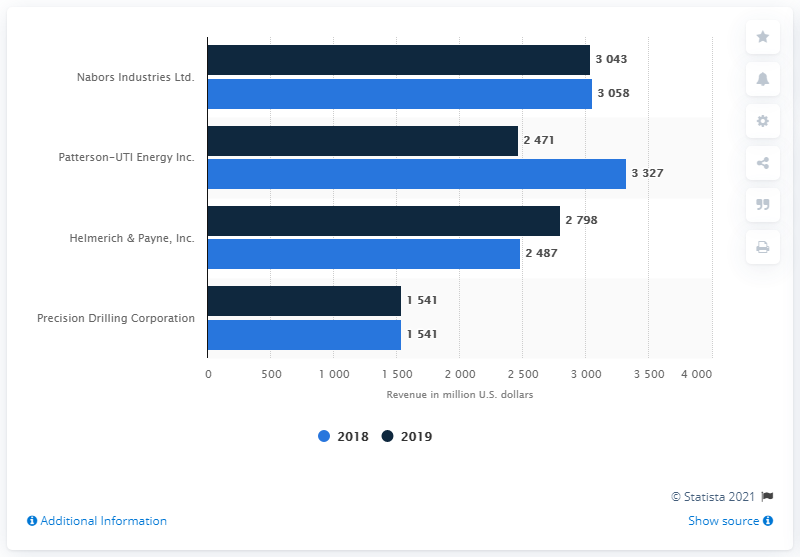Point out several critical features in this image. Precision Drilling Corporation, a land drilling company, has two bars of the same length. Helmerich & Payne, Inc. was the land drilling company with the largest increase in revenue from 2018 to 2019. 